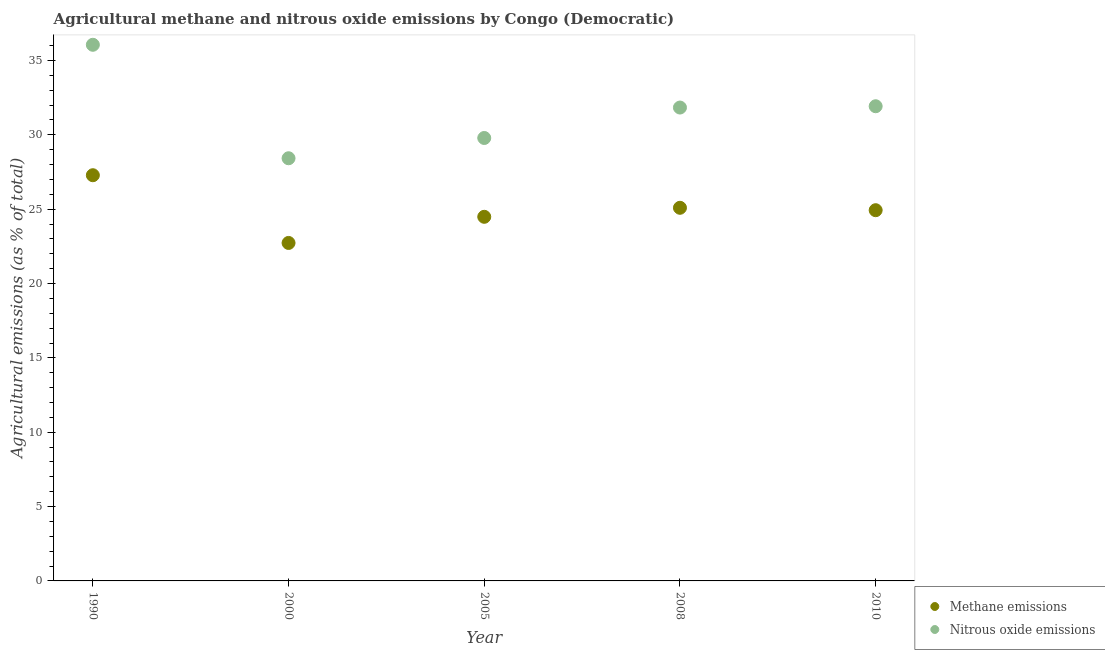What is the amount of nitrous oxide emissions in 2008?
Provide a short and direct response. 31.84. Across all years, what is the maximum amount of methane emissions?
Your answer should be very brief. 27.28. Across all years, what is the minimum amount of methane emissions?
Make the answer very short. 22.73. In which year was the amount of methane emissions maximum?
Offer a very short reply. 1990. What is the total amount of nitrous oxide emissions in the graph?
Offer a terse response. 158.03. What is the difference between the amount of methane emissions in 2000 and that in 2005?
Make the answer very short. -1.76. What is the difference between the amount of nitrous oxide emissions in 1990 and the amount of methane emissions in 2008?
Offer a very short reply. 10.96. What is the average amount of methane emissions per year?
Give a very brief answer. 24.91. In the year 2008, what is the difference between the amount of nitrous oxide emissions and amount of methane emissions?
Ensure brevity in your answer.  6.74. What is the ratio of the amount of methane emissions in 1990 to that in 2005?
Your answer should be compact. 1.11. Is the amount of nitrous oxide emissions in 1990 less than that in 2000?
Your answer should be very brief. No. Is the difference between the amount of methane emissions in 2000 and 2005 greater than the difference between the amount of nitrous oxide emissions in 2000 and 2005?
Offer a terse response. No. What is the difference between the highest and the second highest amount of methane emissions?
Ensure brevity in your answer.  2.19. What is the difference between the highest and the lowest amount of methane emissions?
Your answer should be compact. 4.55. Is the sum of the amount of nitrous oxide emissions in 2005 and 2010 greater than the maximum amount of methane emissions across all years?
Give a very brief answer. Yes. Does the amount of nitrous oxide emissions monotonically increase over the years?
Offer a terse response. No. Is the amount of methane emissions strictly less than the amount of nitrous oxide emissions over the years?
Keep it short and to the point. Yes. How many dotlines are there?
Offer a very short reply. 2. Does the graph contain any zero values?
Offer a terse response. No. Does the graph contain grids?
Provide a short and direct response. No. How many legend labels are there?
Ensure brevity in your answer.  2. What is the title of the graph?
Make the answer very short. Agricultural methane and nitrous oxide emissions by Congo (Democratic). What is the label or title of the X-axis?
Provide a succinct answer. Year. What is the label or title of the Y-axis?
Keep it short and to the point. Agricultural emissions (as % of total). What is the Agricultural emissions (as % of total) of Methane emissions in 1990?
Ensure brevity in your answer.  27.28. What is the Agricultural emissions (as % of total) of Nitrous oxide emissions in 1990?
Your answer should be compact. 36.06. What is the Agricultural emissions (as % of total) of Methane emissions in 2000?
Your answer should be compact. 22.73. What is the Agricultural emissions (as % of total) of Nitrous oxide emissions in 2000?
Offer a terse response. 28.43. What is the Agricultural emissions (as % of total) of Methane emissions in 2005?
Give a very brief answer. 24.49. What is the Agricultural emissions (as % of total) in Nitrous oxide emissions in 2005?
Your answer should be compact. 29.79. What is the Agricultural emissions (as % of total) in Methane emissions in 2008?
Offer a terse response. 25.09. What is the Agricultural emissions (as % of total) of Nitrous oxide emissions in 2008?
Provide a succinct answer. 31.84. What is the Agricultural emissions (as % of total) in Methane emissions in 2010?
Your answer should be compact. 24.93. What is the Agricultural emissions (as % of total) of Nitrous oxide emissions in 2010?
Your answer should be very brief. 31.92. Across all years, what is the maximum Agricultural emissions (as % of total) in Methane emissions?
Your answer should be compact. 27.28. Across all years, what is the maximum Agricultural emissions (as % of total) of Nitrous oxide emissions?
Provide a short and direct response. 36.06. Across all years, what is the minimum Agricultural emissions (as % of total) of Methane emissions?
Provide a short and direct response. 22.73. Across all years, what is the minimum Agricultural emissions (as % of total) of Nitrous oxide emissions?
Offer a terse response. 28.43. What is the total Agricultural emissions (as % of total) in Methane emissions in the graph?
Make the answer very short. 124.53. What is the total Agricultural emissions (as % of total) in Nitrous oxide emissions in the graph?
Make the answer very short. 158.03. What is the difference between the Agricultural emissions (as % of total) of Methane emissions in 1990 and that in 2000?
Offer a very short reply. 4.55. What is the difference between the Agricultural emissions (as % of total) in Nitrous oxide emissions in 1990 and that in 2000?
Give a very brief answer. 7.63. What is the difference between the Agricultural emissions (as % of total) of Methane emissions in 1990 and that in 2005?
Your response must be concise. 2.8. What is the difference between the Agricultural emissions (as % of total) of Nitrous oxide emissions in 1990 and that in 2005?
Ensure brevity in your answer.  6.27. What is the difference between the Agricultural emissions (as % of total) of Methane emissions in 1990 and that in 2008?
Give a very brief answer. 2.19. What is the difference between the Agricultural emissions (as % of total) of Nitrous oxide emissions in 1990 and that in 2008?
Give a very brief answer. 4.22. What is the difference between the Agricultural emissions (as % of total) in Methane emissions in 1990 and that in 2010?
Your answer should be compact. 2.35. What is the difference between the Agricultural emissions (as % of total) in Nitrous oxide emissions in 1990 and that in 2010?
Offer a very short reply. 4.13. What is the difference between the Agricultural emissions (as % of total) in Methane emissions in 2000 and that in 2005?
Your response must be concise. -1.76. What is the difference between the Agricultural emissions (as % of total) in Nitrous oxide emissions in 2000 and that in 2005?
Your response must be concise. -1.36. What is the difference between the Agricultural emissions (as % of total) of Methane emissions in 2000 and that in 2008?
Make the answer very short. -2.36. What is the difference between the Agricultural emissions (as % of total) of Nitrous oxide emissions in 2000 and that in 2008?
Your response must be concise. -3.41. What is the difference between the Agricultural emissions (as % of total) in Methane emissions in 2000 and that in 2010?
Keep it short and to the point. -2.2. What is the difference between the Agricultural emissions (as % of total) in Nitrous oxide emissions in 2000 and that in 2010?
Offer a very short reply. -3.5. What is the difference between the Agricultural emissions (as % of total) of Methane emissions in 2005 and that in 2008?
Your answer should be compact. -0.61. What is the difference between the Agricultural emissions (as % of total) of Nitrous oxide emissions in 2005 and that in 2008?
Make the answer very short. -2.05. What is the difference between the Agricultural emissions (as % of total) in Methane emissions in 2005 and that in 2010?
Your answer should be compact. -0.44. What is the difference between the Agricultural emissions (as % of total) of Nitrous oxide emissions in 2005 and that in 2010?
Your answer should be compact. -2.13. What is the difference between the Agricultural emissions (as % of total) in Methane emissions in 2008 and that in 2010?
Your response must be concise. 0.16. What is the difference between the Agricultural emissions (as % of total) in Nitrous oxide emissions in 2008 and that in 2010?
Ensure brevity in your answer.  -0.09. What is the difference between the Agricultural emissions (as % of total) in Methane emissions in 1990 and the Agricultural emissions (as % of total) in Nitrous oxide emissions in 2000?
Ensure brevity in your answer.  -1.14. What is the difference between the Agricultural emissions (as % of total) of Methane emissions in 1990 and the Agricultural emissions (as % of total) of Nitrous oxide emissions in 2005?
Offer a terse response. -2.5. What is the difference between the Agricultural emissions (as % of total) in Methane emissions in 1990 and the Agricultural emissions (as % of total) in Nitrous oxide emissions in 2008?
Give a very brief answer. -4.55. What is the difference between the Agricultural emissions (as % of total) in Methane emissions in 1990 and the Agricultural emissions (as % of total) in Nitrous oxide emissions in 2010?
Keep it short and to the point. -4.64. What is the difference between the Agricultural emissions (as % of total) of Methane emissions in 2000 and the Agricultural emissions (as % of total) of Nitrous oxide emissions in 2005?
Your answer should be very brief. -7.06. What is the difference between the Agricultural emissions (as % of total) of Methane emissions in 2000 and the Agricultural emissions (as % of total) of Nitrous oxide emissions in 2008?
Ensure brevity in your answer.  -9.11. What is the difference between the Agricultural emissions (as % of total) of Methane emissions in 2000 and the Agricultural emissions (as % of total) of Nitrous oxide emissions in 2010?
Give a very brief answer. -9.19. What is the difference between the Agricultural emissions (as % of total) in Methane emissions in 2005 and the Agricultural emissions (as % of total) in Nitrous oxide emissions in 2008?
Provide a succinct answer. -7.35. What is the difference between the Agricultural emissions (as % of total) in Methane emissions in 2005 and the Agricultural emissions (as % of total) in Nitrous oxide emissions in 2010?
Your response must be concise. -7.44. What is the difference between the Agricultural emissions (as % of total) of Methane emissions in 2008 and the Agricultural emissions (as % of total) of Nitrous oxide emissions in 2010?
Provide a succinct answer. -6.83. What is the average Agricultural emissions (as % of total) in Methane emissions per year?
Give a very brief answer. 24.91. What is the average Agricultural emissions (as % of total) of Nitrous oxide emissions per year?
Offer a very short reply. 31.61. In the year 1990, what is the difference between the Agricultural emissions (as % of total) of Methane emissions and Agricultural emissions (as % of total) of Nitrous oxide emissions?
Offer a very short reply. -8.77. In the year 2000, what is the difference between the Agricultural emissions (as % of total) in Methane emissions and Agricultural emissions (as % of total) in Nitrous oxide emissions?
Make the answer very short. -5.7. In the year 2005, what is the difference between the Agricultural emissions (as % of total) in Methane emissions and Agricultural emissions (as % of total) in Nitrous oxide emissions?
Give a very brief answer. -5.3. In the year 2008, what is the difference between the Agricultural emissions (as % of total) in Methane emissions and Agricultural emissions (as % of total) in Nitrous oxide emissions?
Give a very brief answer. -6.74. In the year 2010, what is the difference between the Agricultural emissions (as % of total) in Methane emissions and Agricultural emissions (as % of total) in Nitrous oxide emissions?
Your answer should be very brief. -6.99. What is the ratio of the Agricultural emissions (as % of total) of Methane emissions in 1990 to that in 2000?
Provide a short and direct response. 1.2. What is the ratio of the Agricultural emissions (as % of total) in Nitrous oxide emissions in 1990 to that in 2000?
Offer a terse response. 1.27. What is the ratio of the Agricultural emissions (as % of total) in Methane emissions in 1990 to that in 2005?
Your answer should be compact. 1.11. What is the ratio of the Agricultural emissions (as % of total) in Nitrous oxide emissions in 1990 to that in 2005?
Make the answer very short. 1.21. What is the ratio of the Agricultural emissions (as % of total) in Methane emissions in 1990 to that in 2008?
Give a very brief answer. 1.09. What is the ratio of the Agricultural emissions (as % of total) in Nitrous oxide emissions in 1990 to that in 2008?
Provide a succinct answer. 1.13. What is the ratio of the Agricultural emissions (as % of total) of Methane emissions in 1990 to that in 2010?
Give a very brief answer. 1.09. What is the ratio of the Agricultural emissions (as % of total) of Nitrous oxide emissions in 1990 to that in 2010?
Ensure brevity in your answer.  1.13. What is the ratio of the Agricultural emissions (as % of total) of Methane emissions in 2000 to that in 2005?
Give a very brief answer. 0.93. What is the ratio of the Agricultural emissions (as % of total) of Nitrous oxide emissions in 2000 to that in 2005?
Provide a succinct answer. 0.95. What is the ratio of the Agricultural emissions (as % of total) in Methane emissions in 2000 to that in 2008?
Provide a succinct answer. 0.91. What is the ratio of the Agricultural emissions (as % of total) in Nitrous oxide emissions in 2000 to that in 2008?
Provide a succinct answer. 0.89. What is the ratio of the Agricultural emissions (as % of total) in Methane emissions in 2000 to that in 2010?
Provide a succinct answer. 0.91. What is the ratio of the Agricultural emissions (as % of total) in Nitrous oxide emissions in 2000 to that in 2010?
Your answer should be compact. 0.89. What is the ratio of the Agricultural emissions (as % of total) in Methane emissions in 2005 to that in 2008?
Make the answer very short. 0.98. What is the ratio of the Agricultural emissions (as % of total) in Nitrous oxide emissions in 2005 to that in 2008?
Ensure brevity in your answer.  0.94. What is the ratio of the Agricultural emissions (as % of total) of Methane emissions in 2005 to that in 2010?
Offer a terse response. 0.98. What is the ratio of the Agricultural emissions (as % of total) in Nitrous oxide emissions in 2005 to that in 2010?
Provide a short and direct response. 0.93. What is the ratio of the Agricultural emissions (as % of total) in Methane emissions in 2008 to that in 2010?
Provide a succinct answer. 1.01. What is the ratio of the Agricultural emissions (as % of total) of Nitrous oxide emissions in 2008 to that in 2010?
Ensure brevity in your answer.  1. What is the difference between the highest and the second highest Agricultural emissions (as % of total) of Methane emissions?
Your response must be concise. 2.19. What is the difference between the highest and the second highest Agricultural emissions (as % of total) in Nitrous oxide emissions?
Offer a terse response. 4.13. What is the difference between the highest and the lowest Agricultural emissions (as % of total) in Methane emissions?
Give a very brief answer. 4.55. What is the difference between the highest and the lowest Agricultural emissions (as % of total) in Nitrous oxide emissions?
Offer a very short reply. 7.63. 